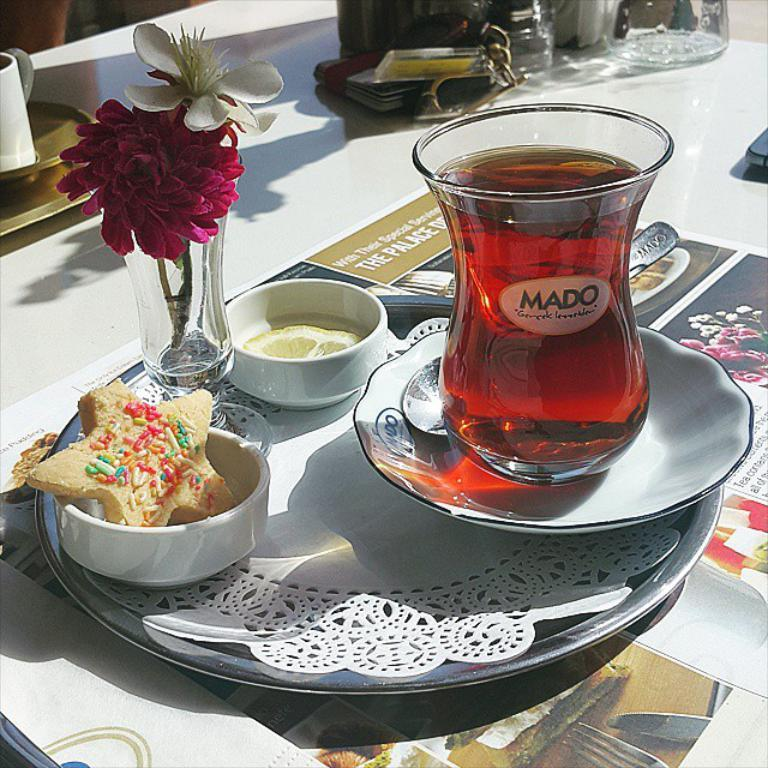What type of furniture is present in the image? There is a table in the image. What objects are placed on the table? There are plates, bowls, and glasses on the table. Can you describe the arrangement of the items on the table? There is a drink in a glass on a plate, and there are two small bowls on the table. What idea is being expressed in the verse written on the table? There is no verse or writing present on the table in the image. 